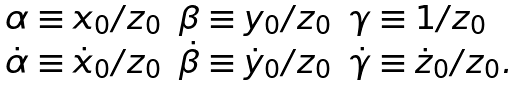<formula> <loc_0><loc_0><loc_500><loc_500>\begin{array} { l l l } \alpha \equiv x _ { 0 } / { z _ { 0 } } & \beta \equiv y _ { 0 } / { z _ { 0 } } & \gamma \equiv 1 / { z _ { 0 } } \\ \dot { \alpha } \equiv \dot { x } _ { 0 } / { z _ { 0 } } & \dot { \beta } \equiv \dot { y } _ { 0 } / { z _ { 0 } } & \dot { \gamma } \equiv \dot { z } _ { 0 } / { z _ { 0 } } . \end{array}</formula> 